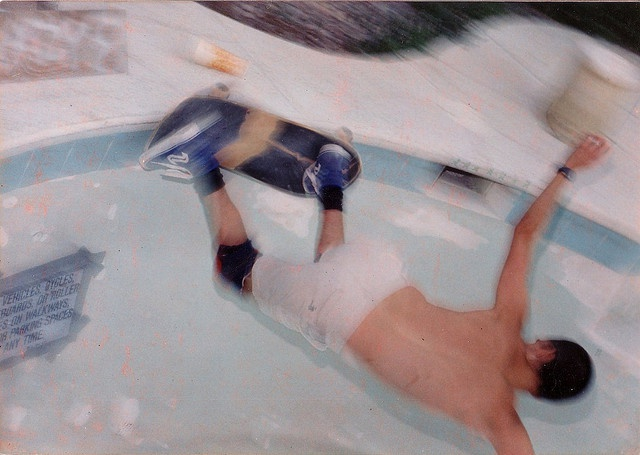Describe the objects in this image and their specific colors. I can see people in white, brown, darkgray, and black tones and skateboard in white, gray, and black tones in this image. 